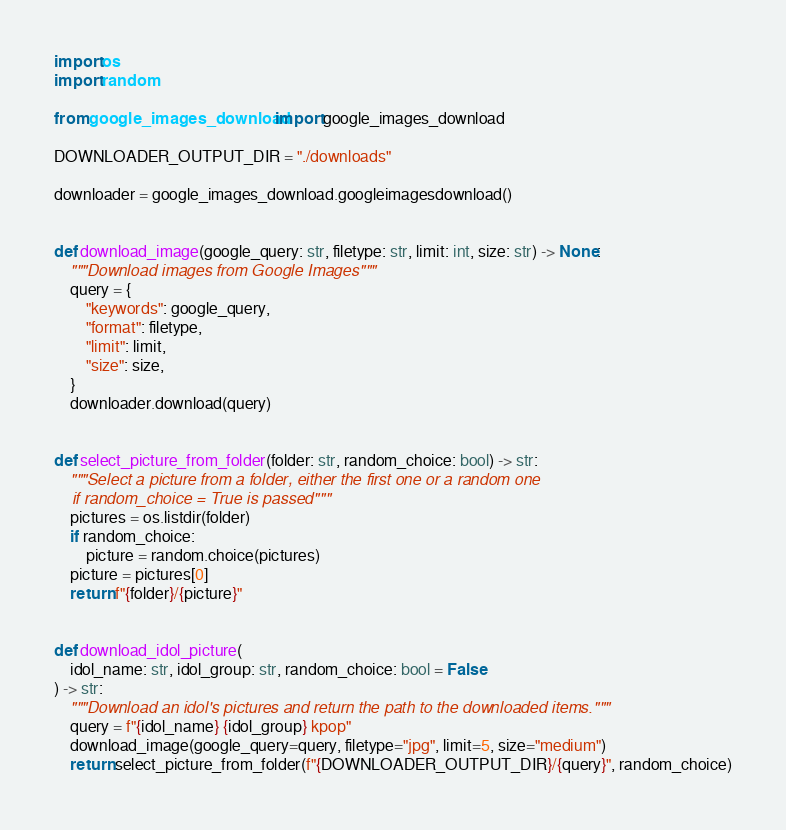<code> <loc_0><loc_0><loc_500><loc_500><_Python_>import os
import random

from google_images_download import google_images_download

DOWNLOADER_OUTPUT_DIR = "./downloads"

downloader = google_images_download.googleimagesdownload()


def download_image(google_query: str, filetype: str, limit: int, size: str) -> None:
    """Download images from Google Images"""
    query = {
        "keywords": google_query,
        "format": filetype,
        "limit": limit,
        "size": size,
    }
    downloader.download(query)


def select_picture_from_folder(folder: str, random_choice: bool) -> str:
    """Select a picture from a folder, either the first one or a random one
    if random_choice = True is passed"""
    pictures = os.listdir(folder)
    if random_choice:
        picture = random.choice(pictures)
    picture = pictures[0]
    return f"{folder}/{picture}"


def download_idol_picture(
    idol_name: str, idol_group: str, random_choice: bool = False
) -> str:
    """Download an idol's pictures and return the path to the downloaded items."""
    query = f"{idol_name} {idol_group} kpop"
    download_image(google_query=query, filetype="jpg", limit=5, size="medium")
    return select_picture_from_folder(f"{DOWNLOADER_OUTPUT_DIR}/{query}", random_choice)
</code> 